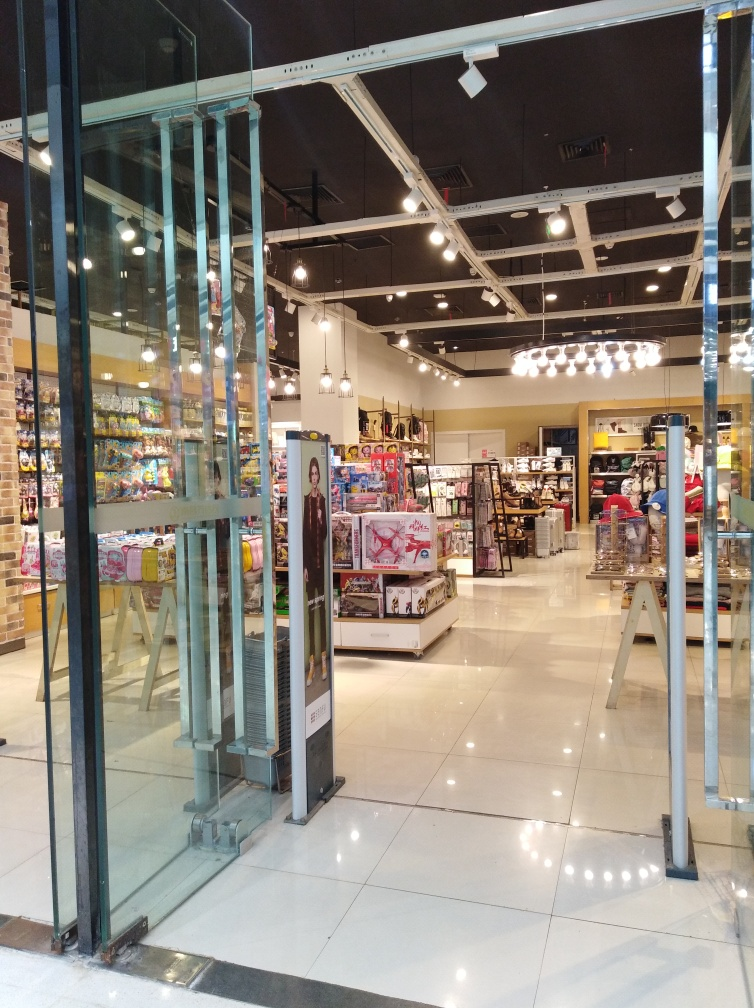What can you tell me about the store's layout and design? The store features an open layout with wide aisles, allowing for comfortable navigation. The design appears modern, with bright lighting fixtures overhead that provide a well-lit shopping environment. Shelving units and promotional displays are strategically placed to attract customers and encourage them to explore the space. What does the layout suggest about the shopping experience? The spacious and orderly arrangement of merchandise implies that the shopping experience is intended to be leisurely and enjoyable. Customers are likely encouraged to take their time browsing the different sections, which can promote a sense of discovery and may enhance the overall retail experience. 